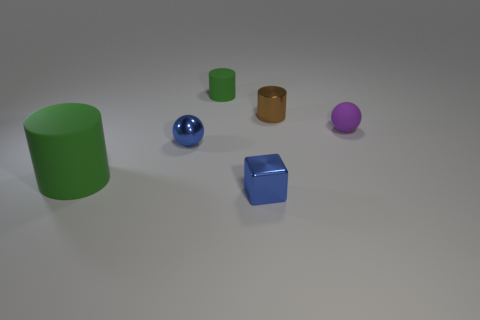Is there another large sphere that has the same color as the metallic sphere?
Provide a succinct answer. No. What size is the blue thing that is made of the same material as the cube?
Keep it short and to the point. Small. Is there any other thing that has the same color as the large rubber cylinder?
Your response must be concise. Yes. There is a rubber cylinder to the right of the large green cylinder; what is its color?
Provide a short and direct response. Green. Is there a blue metal sphere in front of the tiny thing in front of the small sphere on the left side of the small rubber ball?
Provide a succinct answer. No. Is the number of tiny blue things that are behind the brown shiny thing greater than the number of metallic spheres?
Provide a succinct answer. No. There is a green rubber thing that is behind the small brown cylinder; is it the same shape as the large green rubber thing?
Your answer should be very brief. Yes. Is there any other thing that is the same material as the small green cylinder?
Offer a terse response. Yes. How many things are either spheres or green rubber cylinders behind the small brown metallic cylinder?
Offer a very short reply. 3. What size is the matte object that is both on the right side of the small blue ball and in front of the small metal cylinder?
Provide a succinct answer. Small. 